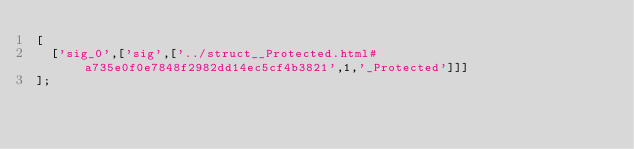<code> <loc_0><loc_0><loc_500><loc_500><_JavaScript_>[
  ['sig_0',['sig',['../struct__Protected.html#a735e0f0e7848f2982dd14ec5cf4b3821',1,'_Protected']]]
];
</code> 